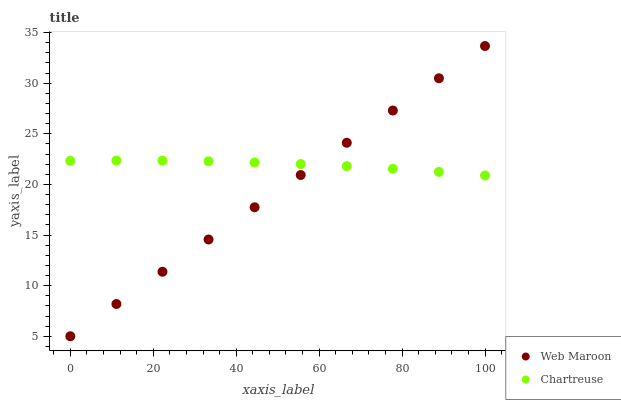Does Web Maroon have the minimum area under the curve?
Answer yes or no. Yes. Does Chartreuse have the maximum area under the curve?
Answer yes or no. Yes. Does Web Maroon have the maximum area under the curve?
Answer yes or no. No. Is Web Maroon the smoothest?
Answer yes or no. Yes. Is Chartreuse the roughest?
Answer yes or no. Yes. Is Web Maroon the roughest?
Answer yes or no. No. Does Web Maroon have the lowest value?
Answer yes or no. Yes. Does Web Maroon have the highest value?
Answer yes or no. Yes. Does Web Maroon intersect Chartreuse?
Answer yes or no. Yes. Is Web Maroon less than Chartreuse?
Answer yes or no. No. Is Web Maroon greater than Chartreuse?
Answer yes or no. No. 